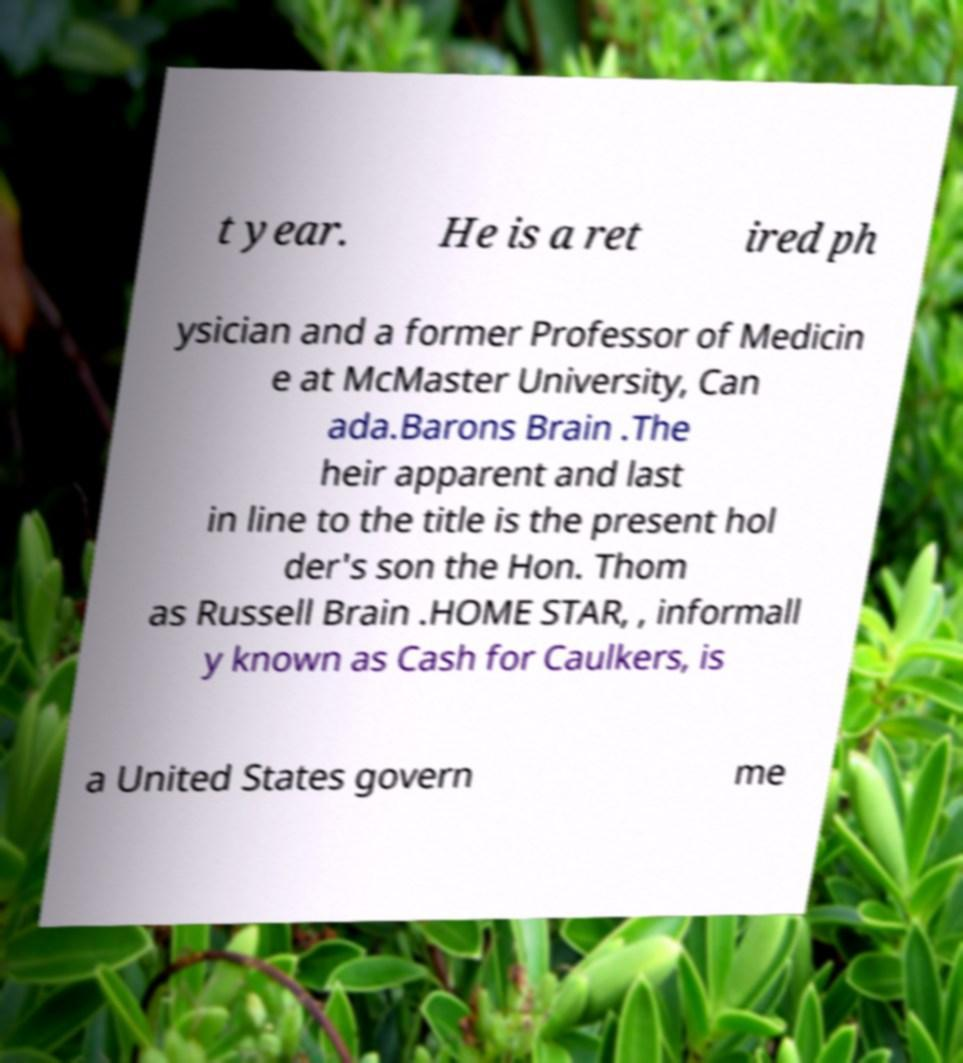Please read and relay the text visible in this image. What does it say? t year. He is a ret ired ph ysician and a former Professor of Medicin e at McMaster University, Can ada.Barons Brain .The heir apparent and last in line to the title is the present hol der's son the Hon. Thom as Russell Brain .HOME STAR, , informall y known as Cash for Caulkers, is a United States govern me 